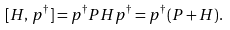Convert formula to latex. <formula><loc_0><loc_0><loc_500><loc_500>[ H , \, p ^ { \dagger } ] = p ^ { \dagger } P H p ^ { \dagger } = p ^ { \dagger } ( P + H ) .</formula> 